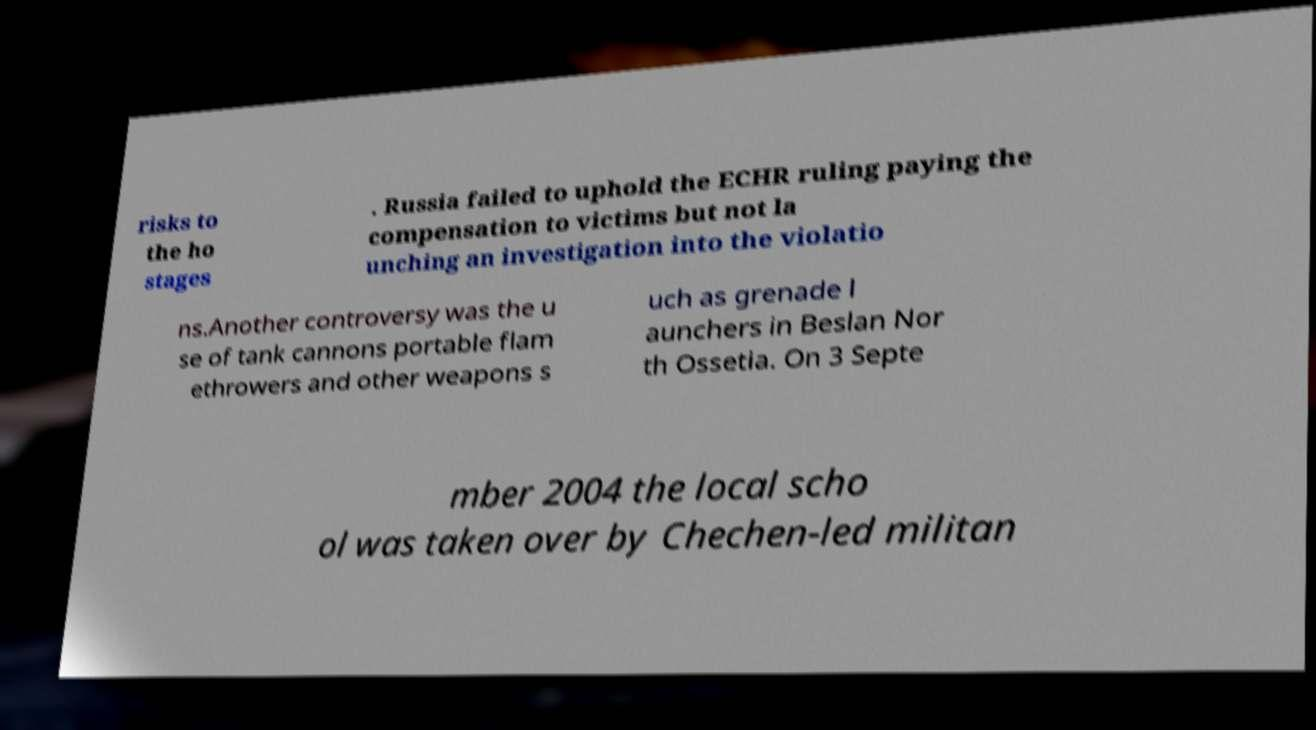I need the written content from this picture converted into text. Can you do that? risks to the ho stages . Russia failed to uphold the ECHR ruling paying the compensation to victims but not la unching an investigation into the violatio ns.Another controversy was the u se of tank cannons portable flam ethrowers and other weapons s uch as grenade l aunchers in Beslan Nor th Ossetia. On 3 Septe mber 2004 the local scho ol was taken over by Chechen-led militan 